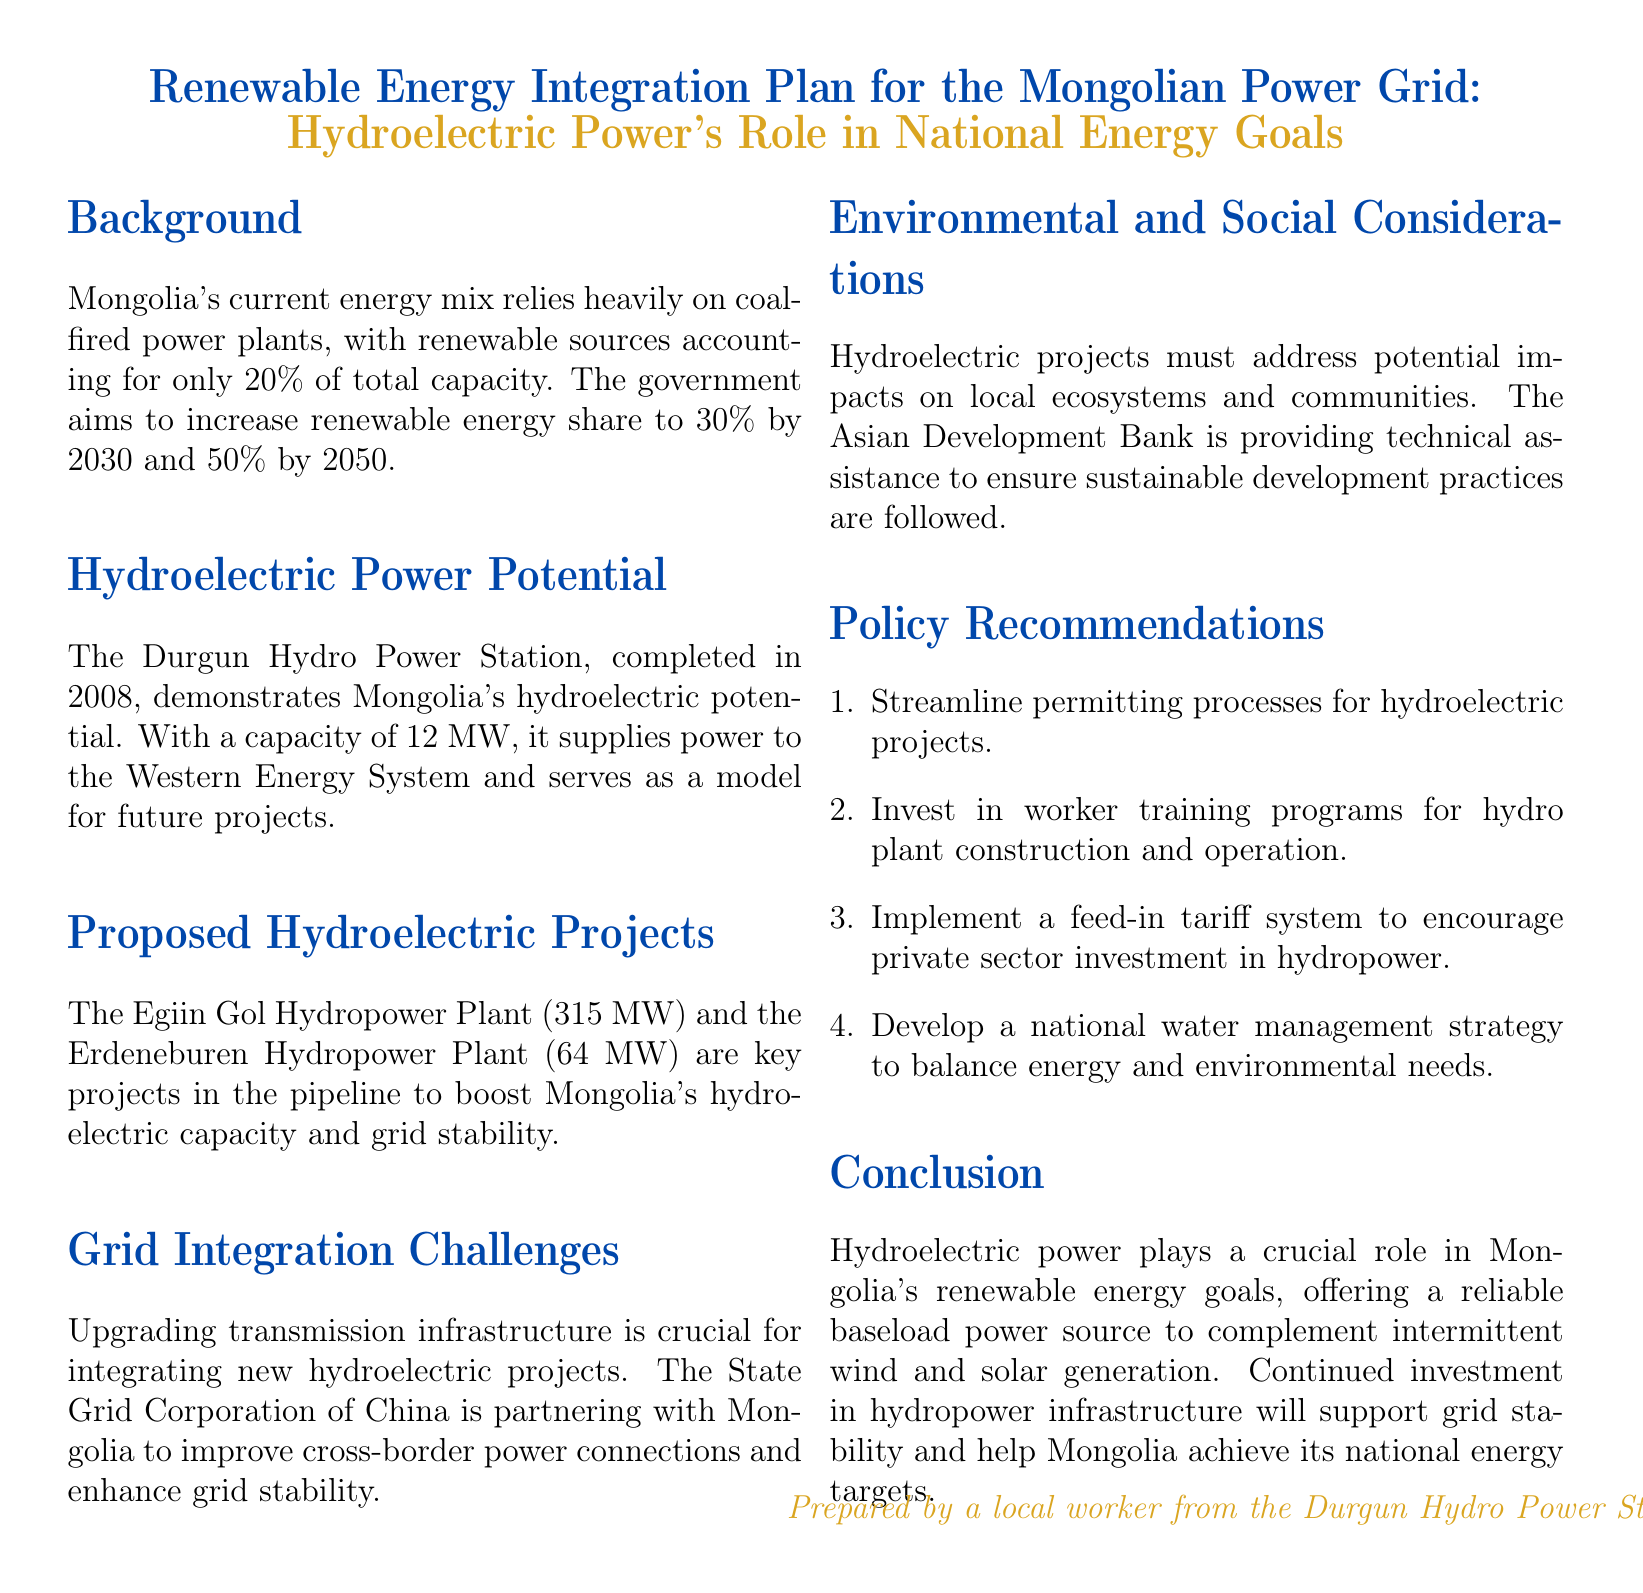What is the current renewable energy share in Mongolia? The document states that renewable sources account for only 20% of total capacity in Mongolia.
Answer: 20% What is the proposed renewable energy share by 2030? The government aims to increase the renewable energy share to 30% by 2030.
Answer: 30% What is the capacity of the Durgun Hydro Power Station? The Durgun Hydro Power Station has a capacity of 12 MW.
Answer: 12 MW What is the capacity of the Egiin Gol Hydropower Plant? The Egiin Gol Hydropower Plant is proposed to have a capacity of 315 MW.
Answer: 315 MW Which organization is partnering with Mongolia for grid stability? The State Grid Corporation of China is partnering with Mongolia.
Answer: State Grid Corporation of China What is one key environmental consideration mentioned? Hydroelectric projects must address potential impacts on local ecosystems and communities.
Answer: Local ecosystems What is one policy recommendation for hydropower projects? Streamline permitting processes for hydroelectric projects is one of the recommendations.
Answer: Streamline permitting processes What potential role does hydroelectric power play in Mongolia's energy goals? Hydroelectric power offers a reliable baseload power source to complement intermittent wind and solar generation.
Answer: Reliable baseload power source What is the expected renewable energy share by 2050? The document states that the government aims for a 50% renewable energy share by 2050.
Answer: 50% 